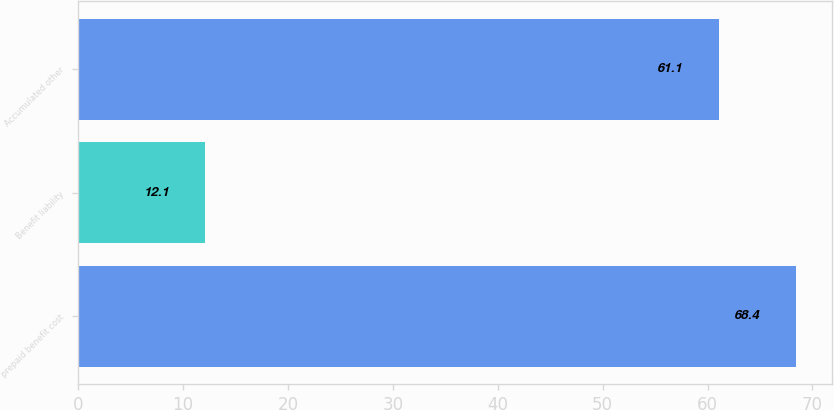Convert chart to OTSL. <chart><loc_0><loc_0><loc_500><loc_500><bar_chart><fcel>prepaid benefit cost<fcel>Benefit liability<fcel>Accumulated other<nl><fcel>68.4<fcel>12.1<fcel>61.1<nl></chart> 